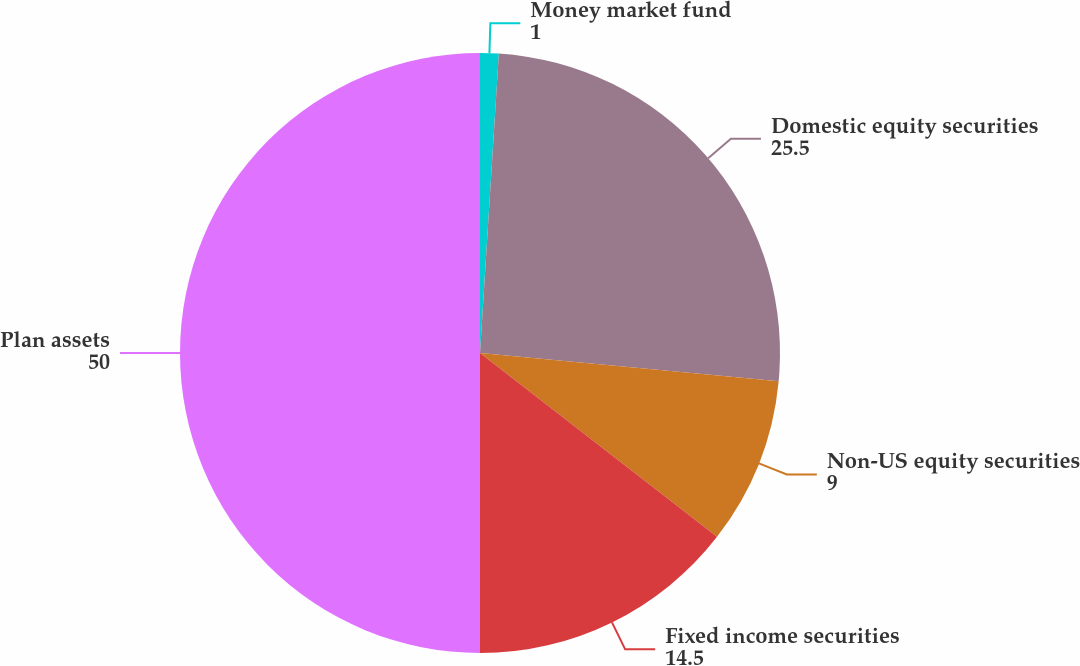<chart> <loc_0><loc_0><loc_500><loc_500><pie_chart><fcel>Money market fund<fcel>Domestic equity securities<fcel>Non-US equity securities<fcel>Fixed income securities<fcel>Plan assets<nl><fcel>1.0%<fcel>25.5%<fcel>9.0%<fcel>14.5%<fcel>50.0%<nl></chart> 